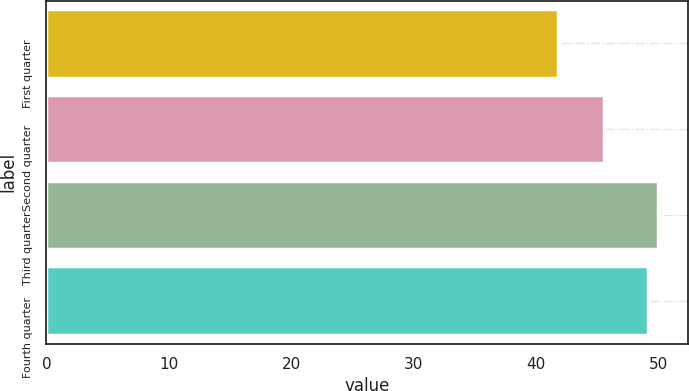Convert chart to OTSL. <chart><loc_0><loc_0><loc_500><loc_500><bar_chart><fcel>First quarter<fcel>Second quarter<fcel>Third quarter<fcel>Fourth quarter<nl><fcel>41.82<fcel>45.56<fcel>49.94<fcel>49.18<nl></chart> 